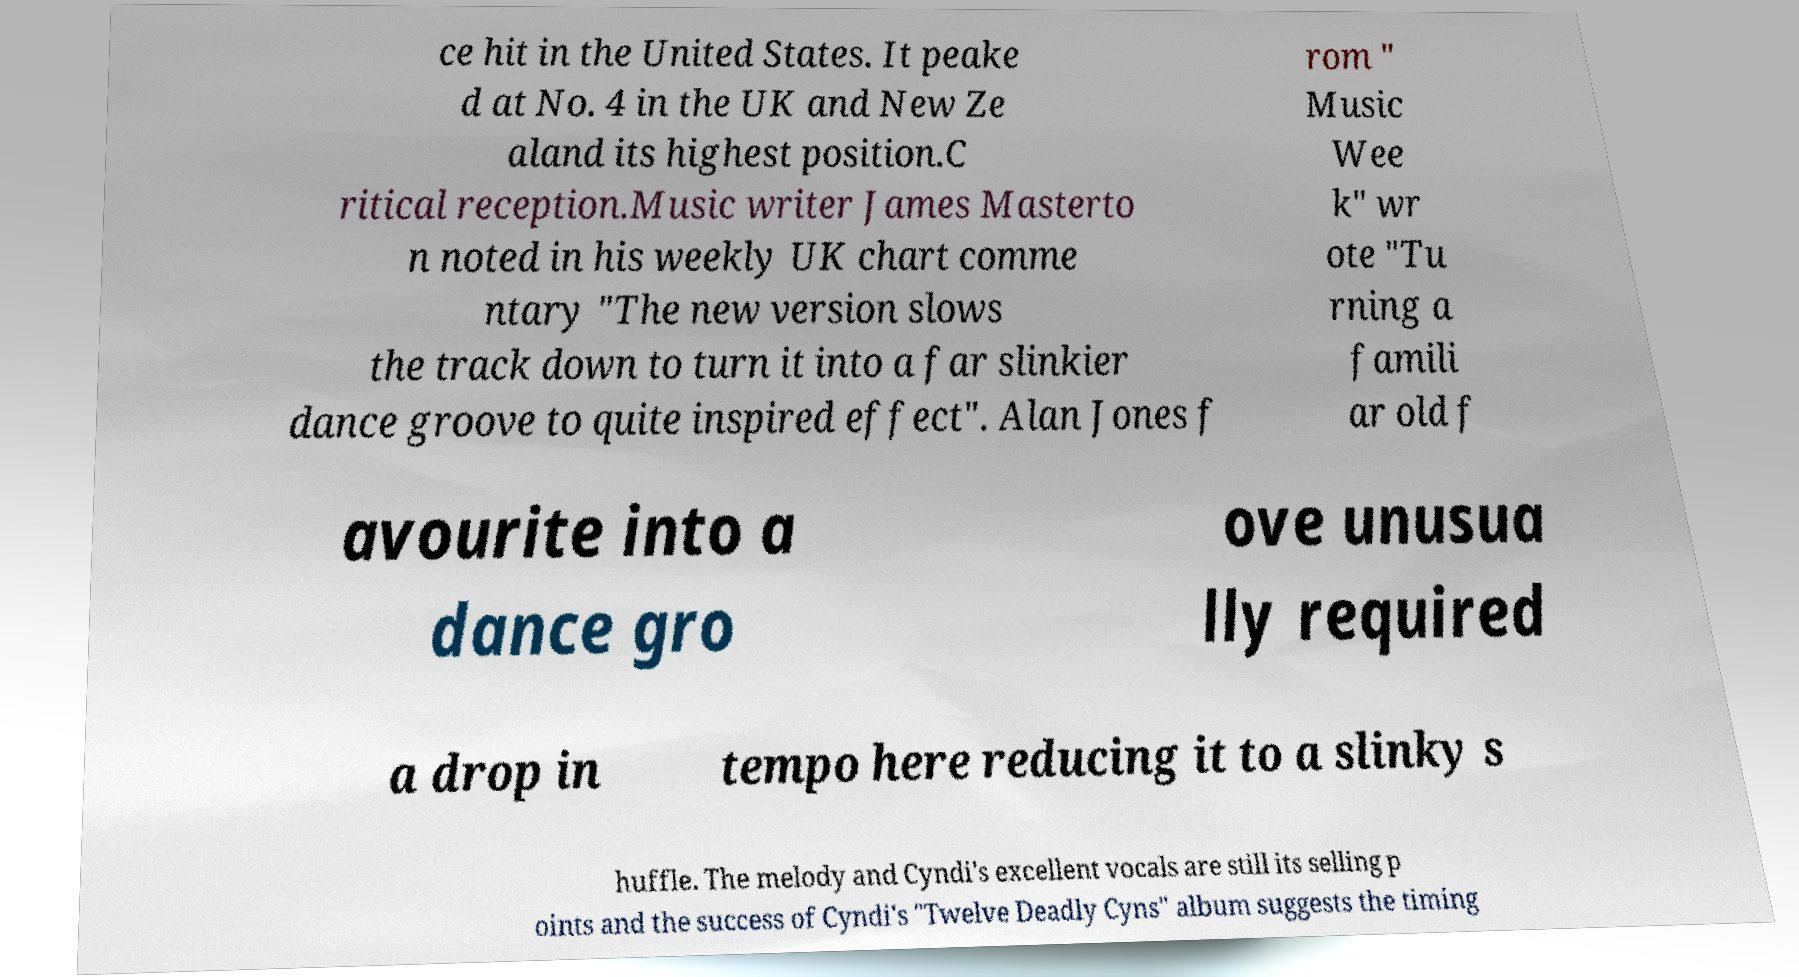What messages or text are displayed in this image? I need them in a readable, typed format. ce hit in the United States. It peake d at No. 4 in the UK and New Ze aland its highest position.C ritical reception.Music writer James Masterto n noted in his weekly UK chart comme ntary "The new version slows the track down to turn it into a far slinkier dance groove to quite inspired effect". Alan Jones f rom " Music Wee k" wr ote "Tu rning a famili ar old f avourite into a dance gro ove unusua lly required a drop in tempo here reducing it to a slinky s huffle. The melody and Cyndi's excellent vocals are still its selling p oints and the success of Cyndi's "Twelve Deadly Cyns" album suggests the timing 